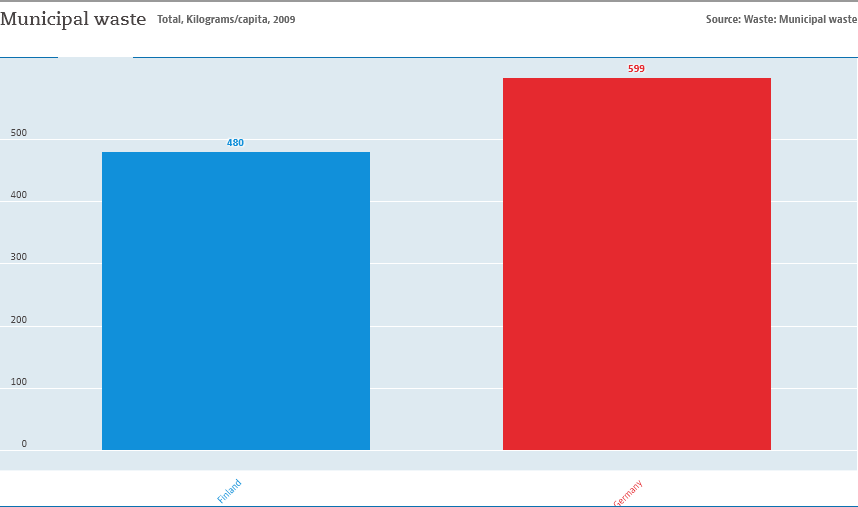Mention a couple of crucial points in this snapshot. The average of Finland and Germany is 539.5. The color of the German bar is red. 